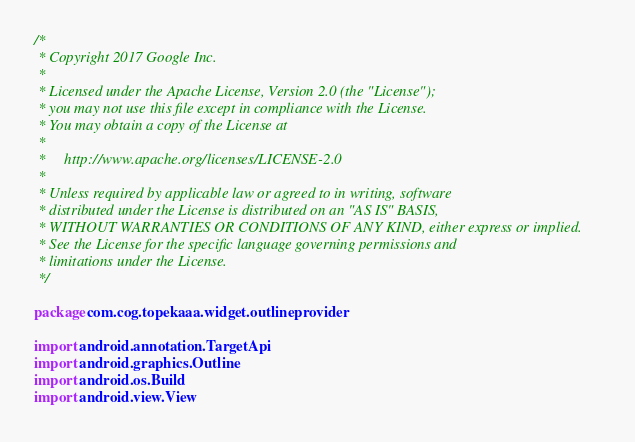Convert code to text. <code><loc_0><loc_0><loc_500><loc_500><_Kotlin_>/*
 * Copyright 2017 Google Inc.
 *
 * Licensed under the Apache License, Version 2.0 (the "License");
 * you may not use this file except in compliance with the License.
 * You may obtain a copy of the License at
 *
 *     http://www.apache.org/licenses/LICENSE-2.0
 *
 * Unless required by applicable law or agreed to in writing, software
 * distributed under the License is distributed on an "AS IS" BASIS,
 * WITHOUT WARRANTIES OR CONDITIONS OF ANY KIND, either express or implied.
 * See the License for the specific language governing permissions and
 * limitations under the License.
 */

package com.cog.topekaaa.widget.outlineprovider

import android.annotation.TargetApi
import android.graphics.Outline
import android.os.Build
import android.view.View</code> 